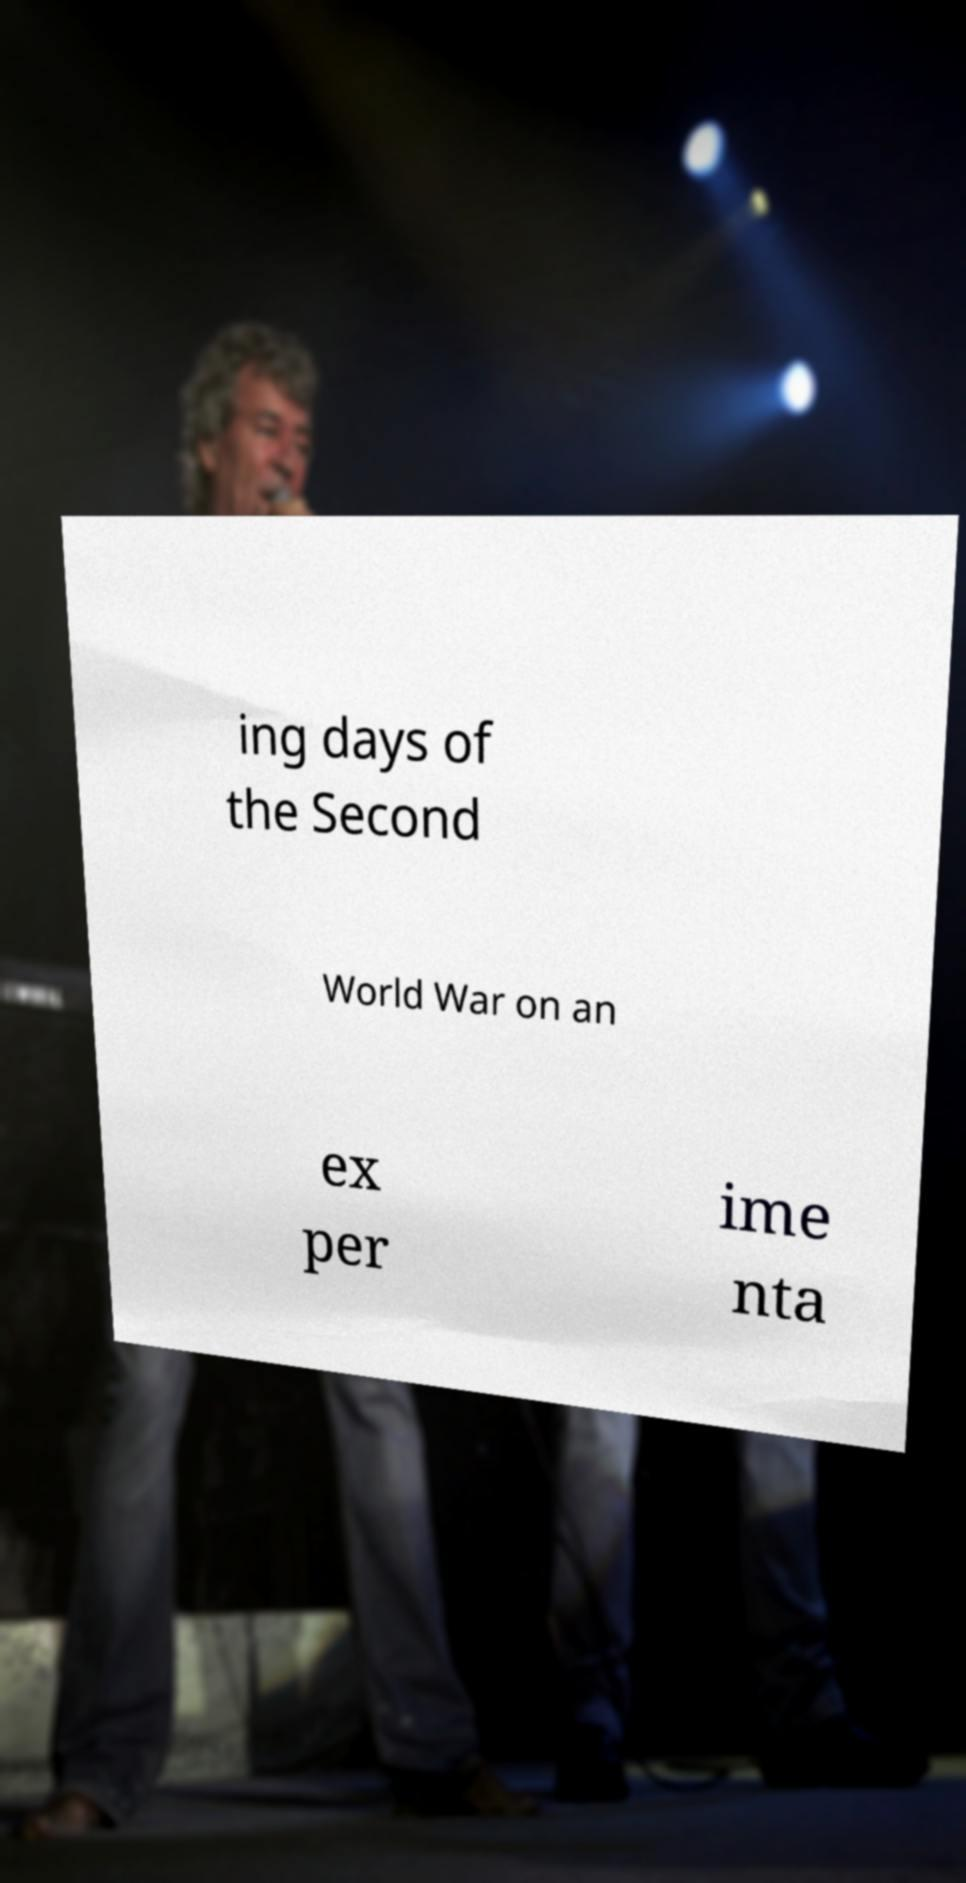For documentation purposes, I need the text within this image transcribed. Could you provide that? ing days of the Second World War on an ex per ime nta 